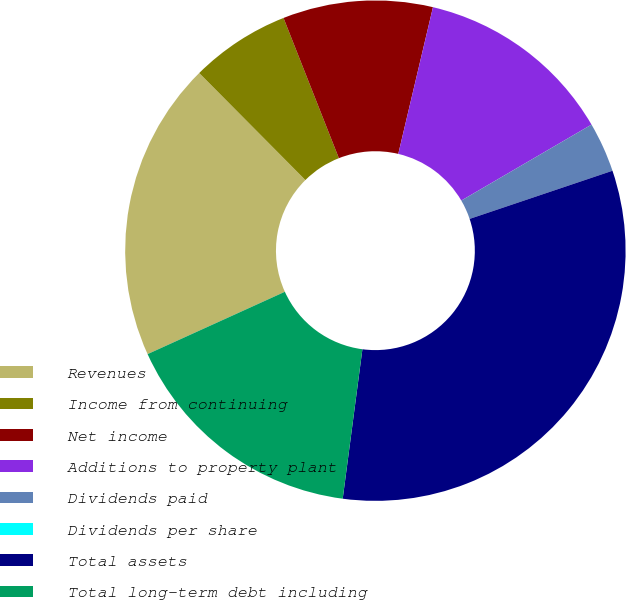Convert chart to OTSL. <chart><loc_0><loc_0><loc_500><loc_500><pie_chart><fcel>Revenues<fcel>Income from continuing<fcel>Net income<fcel>Additions to property plant<fcel>Dividends paid<fcel>Dividends per share<fcel>Total assets<fcel>Total long-term debt including<nl><fcel>19.35%<fcel>6.45%<fcel>9.68%<fcel>12.9%<fcel>3.23%<fcel>0.0%<fcel>32.26%<fcel>16.13%<nl></chart> 